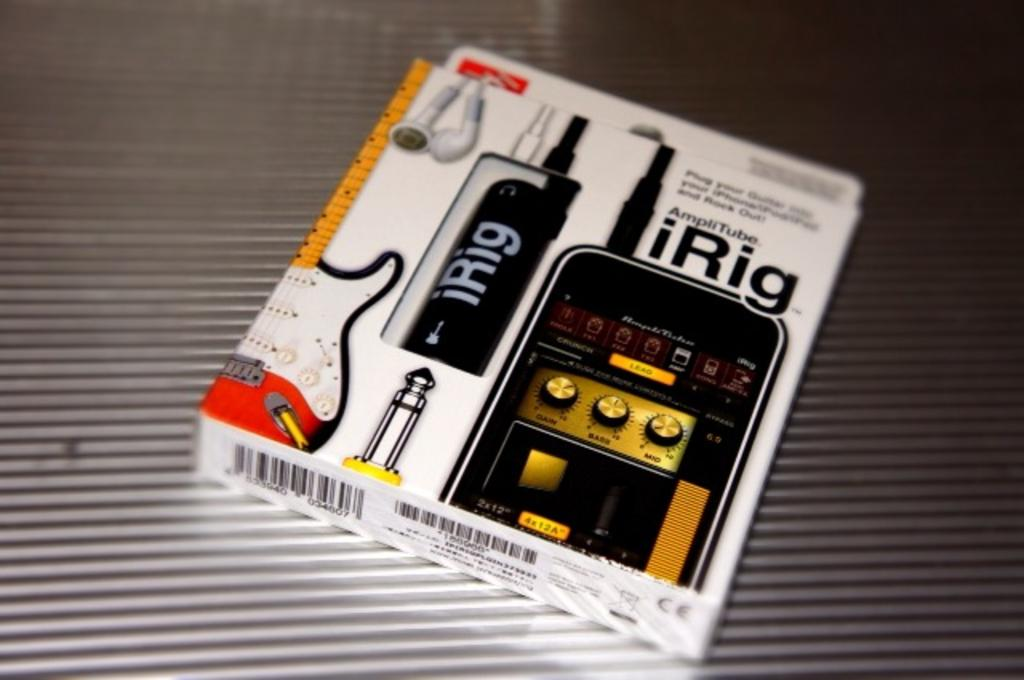Provide a one-sentence caption for the provided image. A cord that acts as an adapter that attaches to an Iphone. 